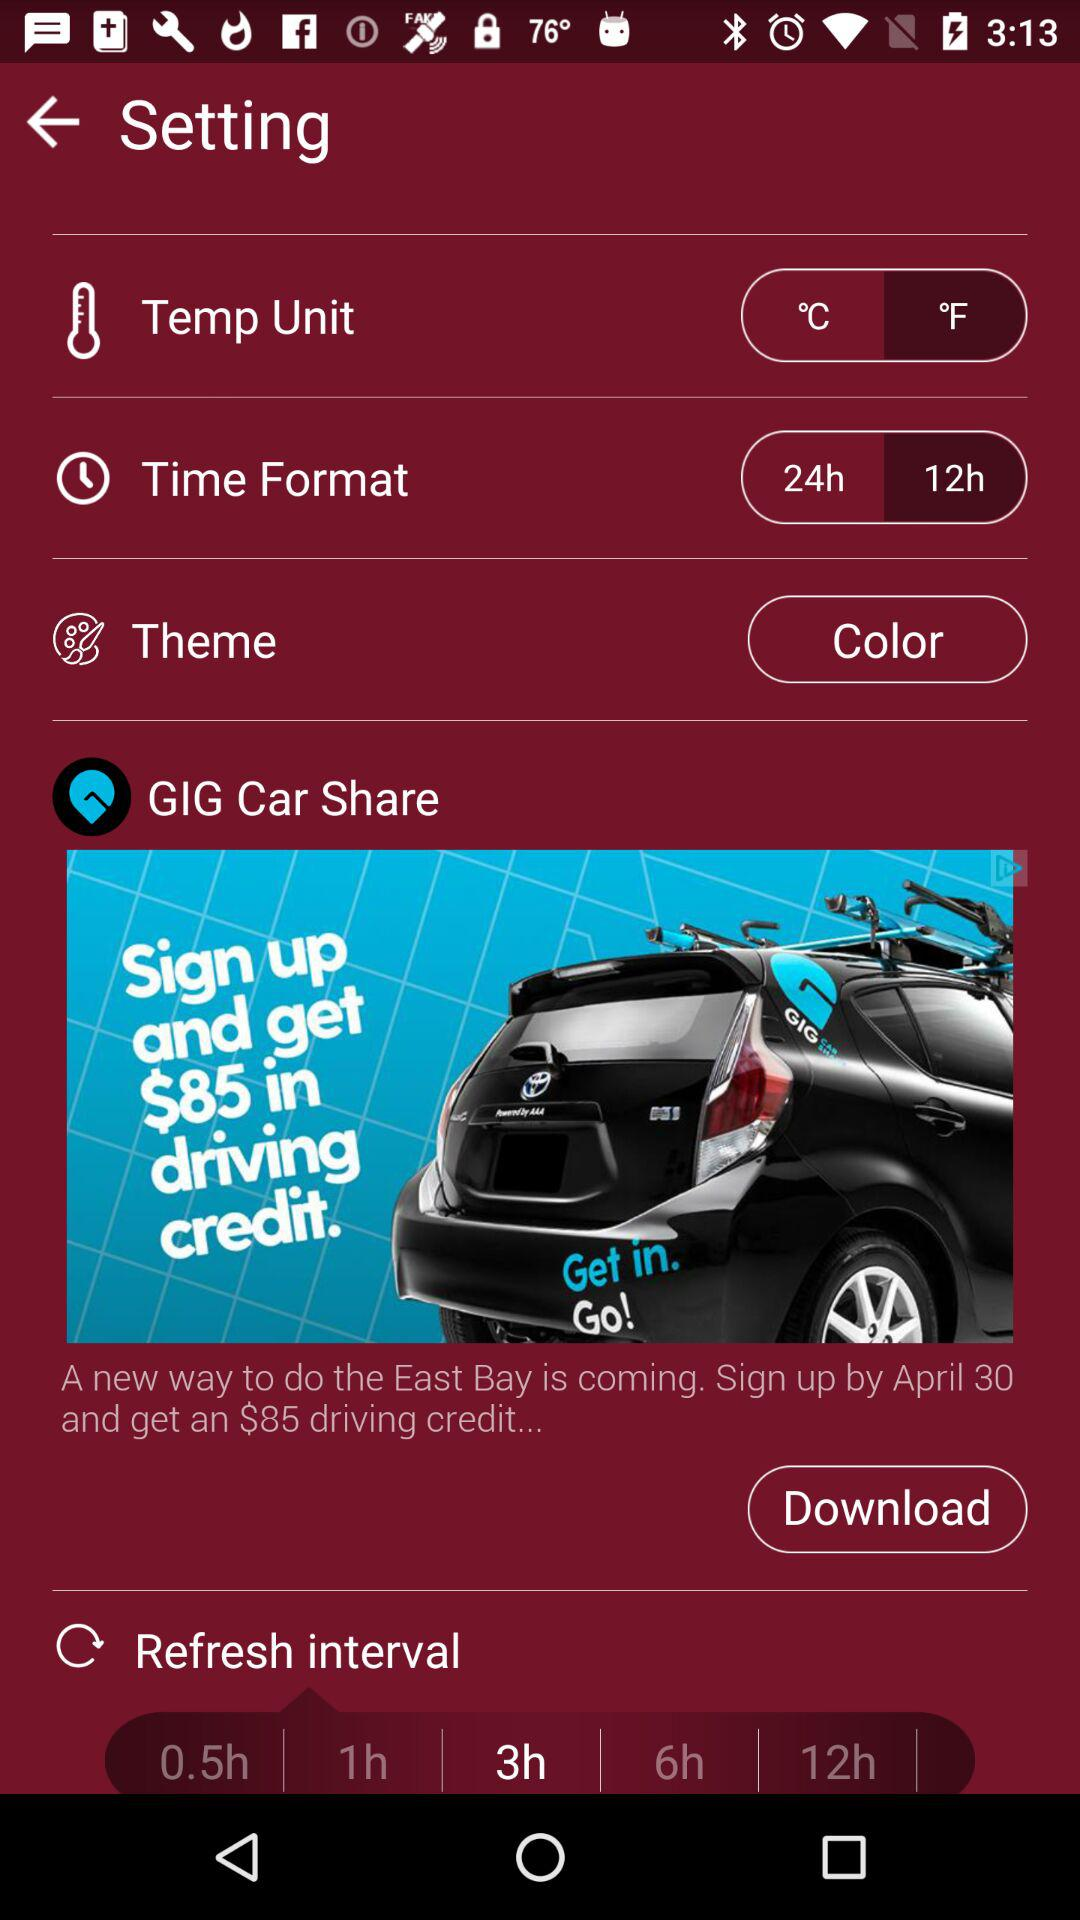What options are available for the time format in the settings? The settings in the image show two options for time format: a 24-hour clock and a 12-hour clock.  Regarding the Refresh Interval setting, what are the different intervals one can choose from? The possible refresh intervals in the settings range from 0.5 hours (30 minutes) up to 12 hours, providing several options for how often the information updates. 